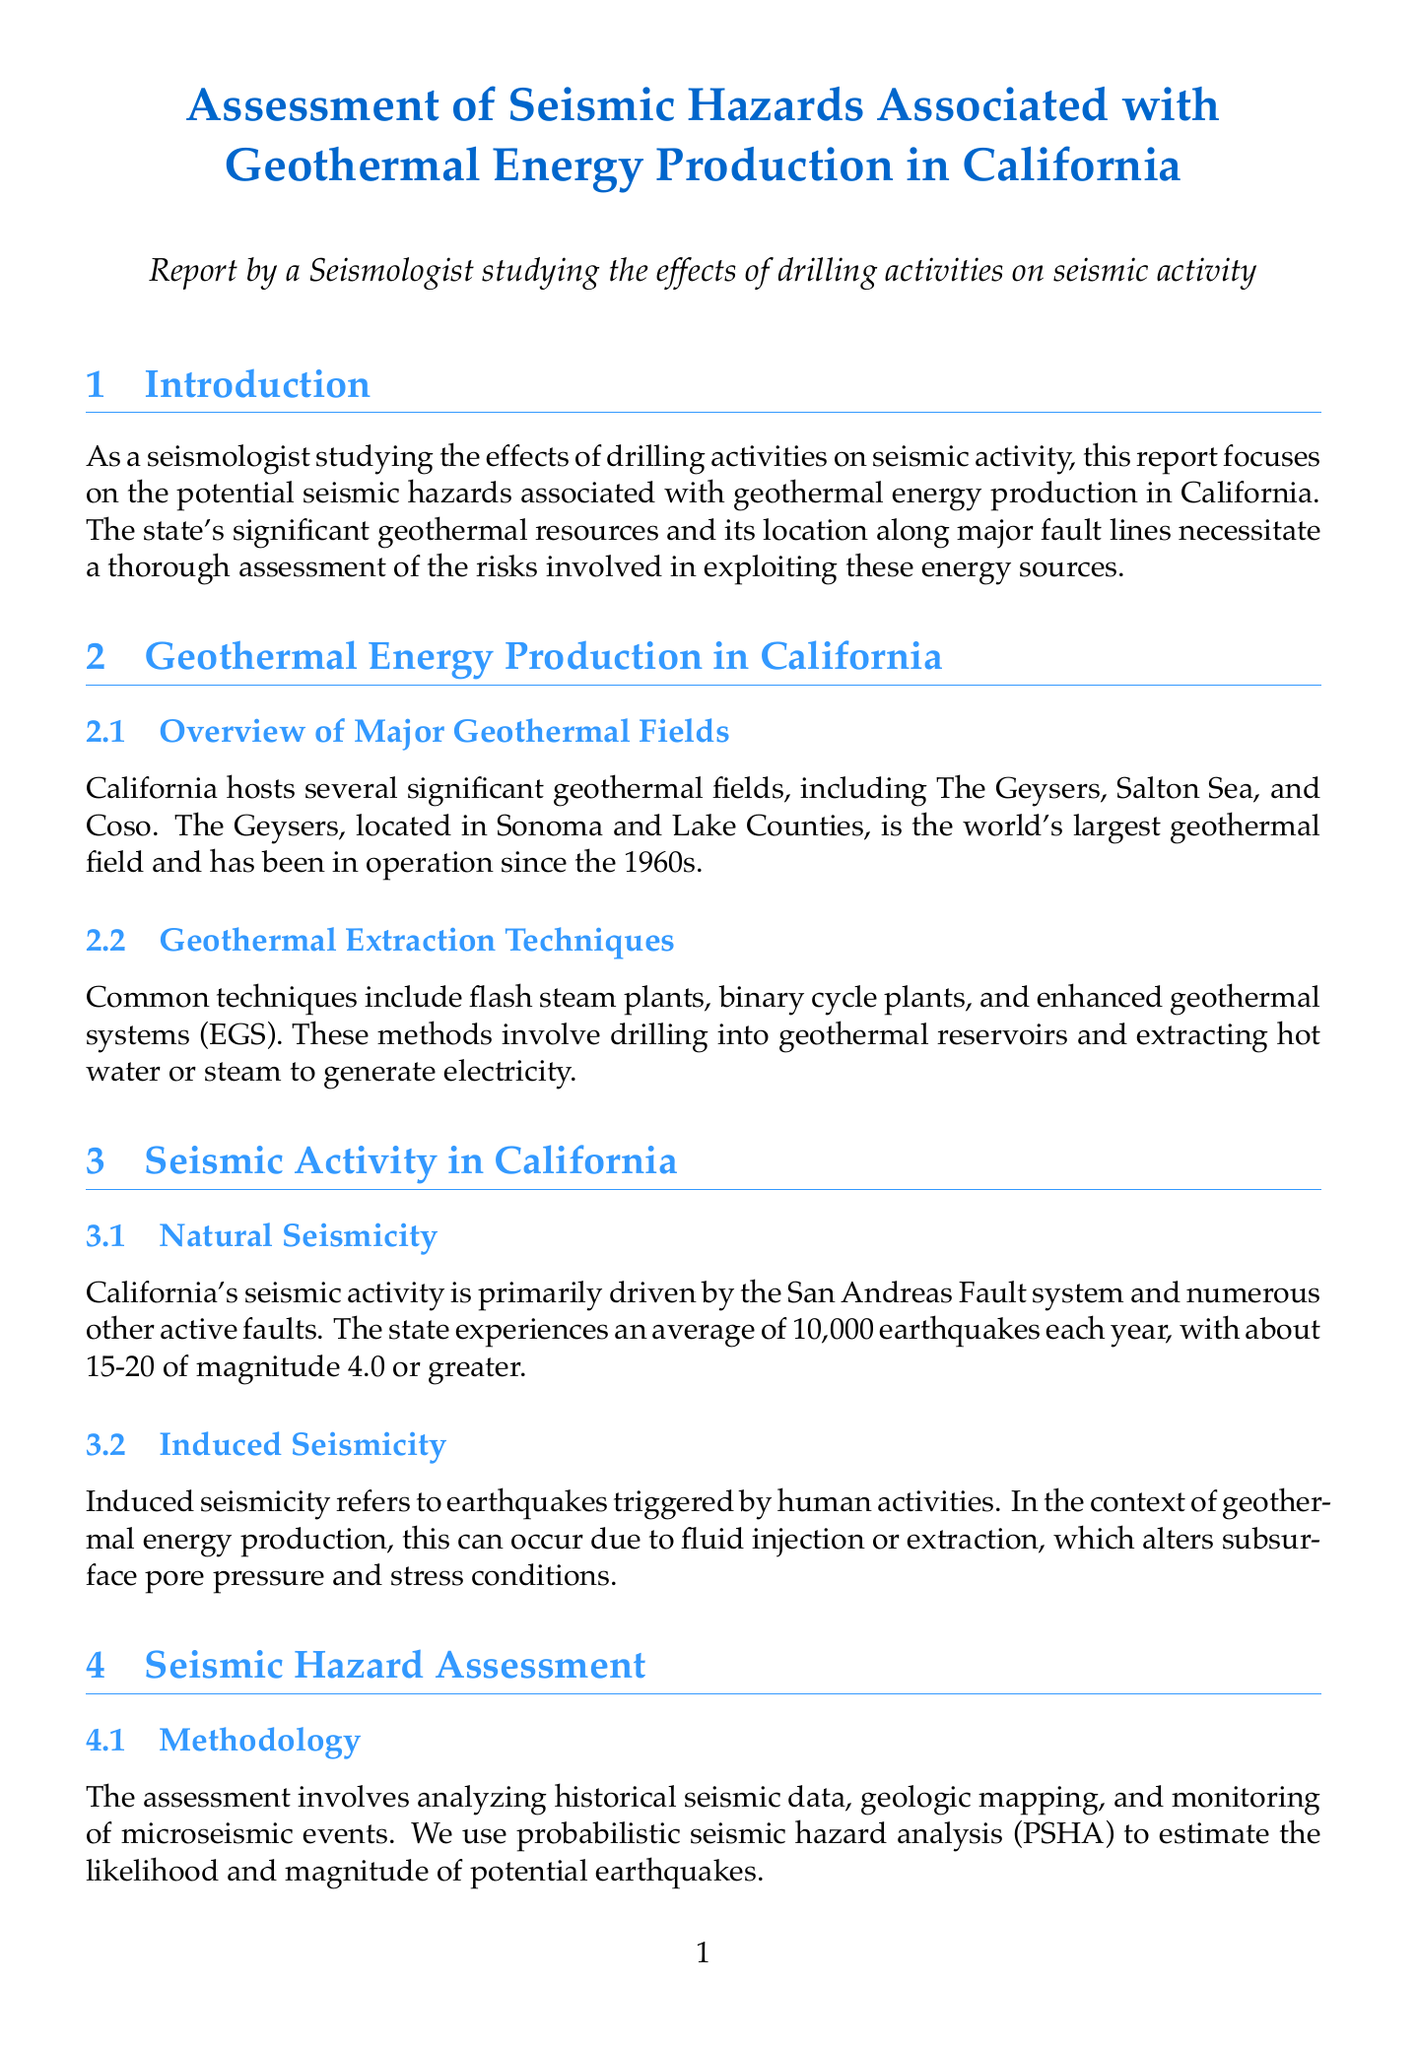what is the title of the report? The title of the report is explicitly mentioned at the beginning of the document.
Answer: Assessment of Seismic Hazards Associated with Geothermal Energy Production in California how many major geothermal fields are mentioned? The document states that California hosts several significant geothermal fields, including The Geysers, Salton Sea, and Coso.
Answer: three what year was the 2016 magnitude 5.0 earthquake linked to The Geysers? The document references the 2016 earthquake in the context of seismic events related to The Geysers.
Answer: 2016 what is a key risk factor for seismic hazards in geothermal areas? The report lists several risk factors, including proximity to active faults, injection/extraction rates, reservoir pressure changes, and local geology.
Answer: proximity to active faults which organization provides the statewide seismic hazard map? The document cites the California Geological Survey as the provider of the statewide seismic hazard map.
Answer: California Geological Survey what technique is commonly used for geothermal extraction? The report describes various techniques used in geothermal energy production, including flash steam plants, binary cycle plants, and enhanced geothermal systems.
Answer: flash steam plants what type of seismicity can occur due to geothermal energy production? The report discusses induced seismicity as a phenomenon triggered by human activities related to geothermal energy.
Answer: induced seismicity which area is noted for higher seismic risks due to geothermal activity? The risk factors section mentions the Imperial Valley as an area presenting higher risks due to its geothermal activity.
Answer: Imperial Valley what is one of the mitigation strategies suggested in the report? The document outlines several strategies, including controlled injection rates and real-time seismic monitoring.
Answer: controlled injection rates 